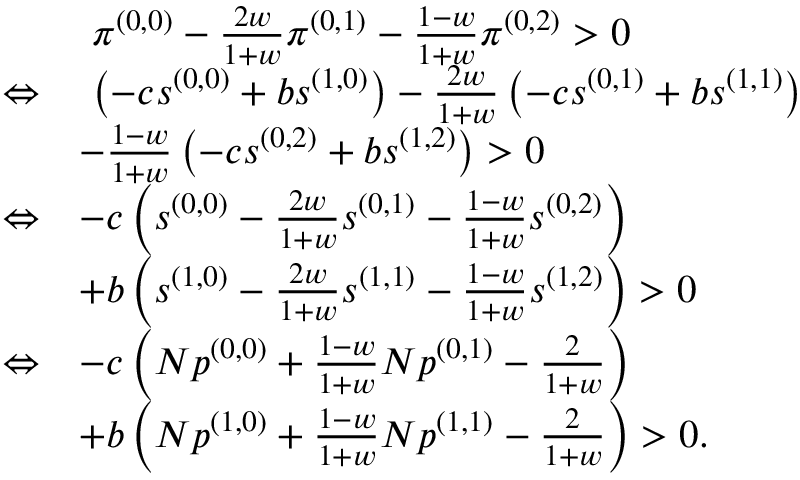<formula> <loc_0><loc_0><loc_500><loc_500>\begin{array} { r l } & { \pi ^ { ( 0 , 0 ) } - \frac { 2 w } { 1 + w } \pi ^ { ( 0 , 1 ) } - \frac { 1 - w } { 1 + w } \pi ^ { ( 0 , 2 ) } > 0 } \\ { \Leftrightarrow } & { \left ( - c s ^ { ( 0 , 0 ) } + b s ^ { ( 1 , 0 ) } \right ) - \frac { 2 w } { 1 + w } \left ( - c s ^ { ( 0 , 1 ) } + b s ^ { ( 1 , 1 ) } \right ) } \\ & { - \frac { 1 - w } { 1 + w } \left ( - c s ^ { ( 0 , 2 ) } + b s ^ { ( 1 , 2 ) } \right ) > 0 } \\ { \Leftrightarrow } & { - c \left ( s ^ { ( 0 , 0 ) } - \frac { 2 w } { 1 + w } s ^ { ( 0 , 1 ) } - \frac { 1 - w } { 1 + w } s ^ { ( 0 , 2 ) } \right ) } \\ & { + b \left ( s ^ { ( 1 , 0 ) } - \frac { 2 w } { 1 + w } s ^ { ( 1 , 1 ) } - \frac { 1 - w } { 1 + w } s ^ { ( 1 , 2 ) } \right ) > 0 } \\ { \Leftrightarrow } & { - c \left ( N p ^ { ( 0 , 0 ) } + \frac { 1 - w } { 1 + w } N p ^ { ( 0 , 1 ) } - \frac { 2 } { 1 + w } \right ) } \\ & { + b \left ( N p ^ { ( 1 , 0 ) } + \frac { 1 - w } { 1 + w } N p ^ { ( 1 , 1 ) } - \frac { 2 } { 1 + w } \right ) > 0 . } \end{array}</formula> 